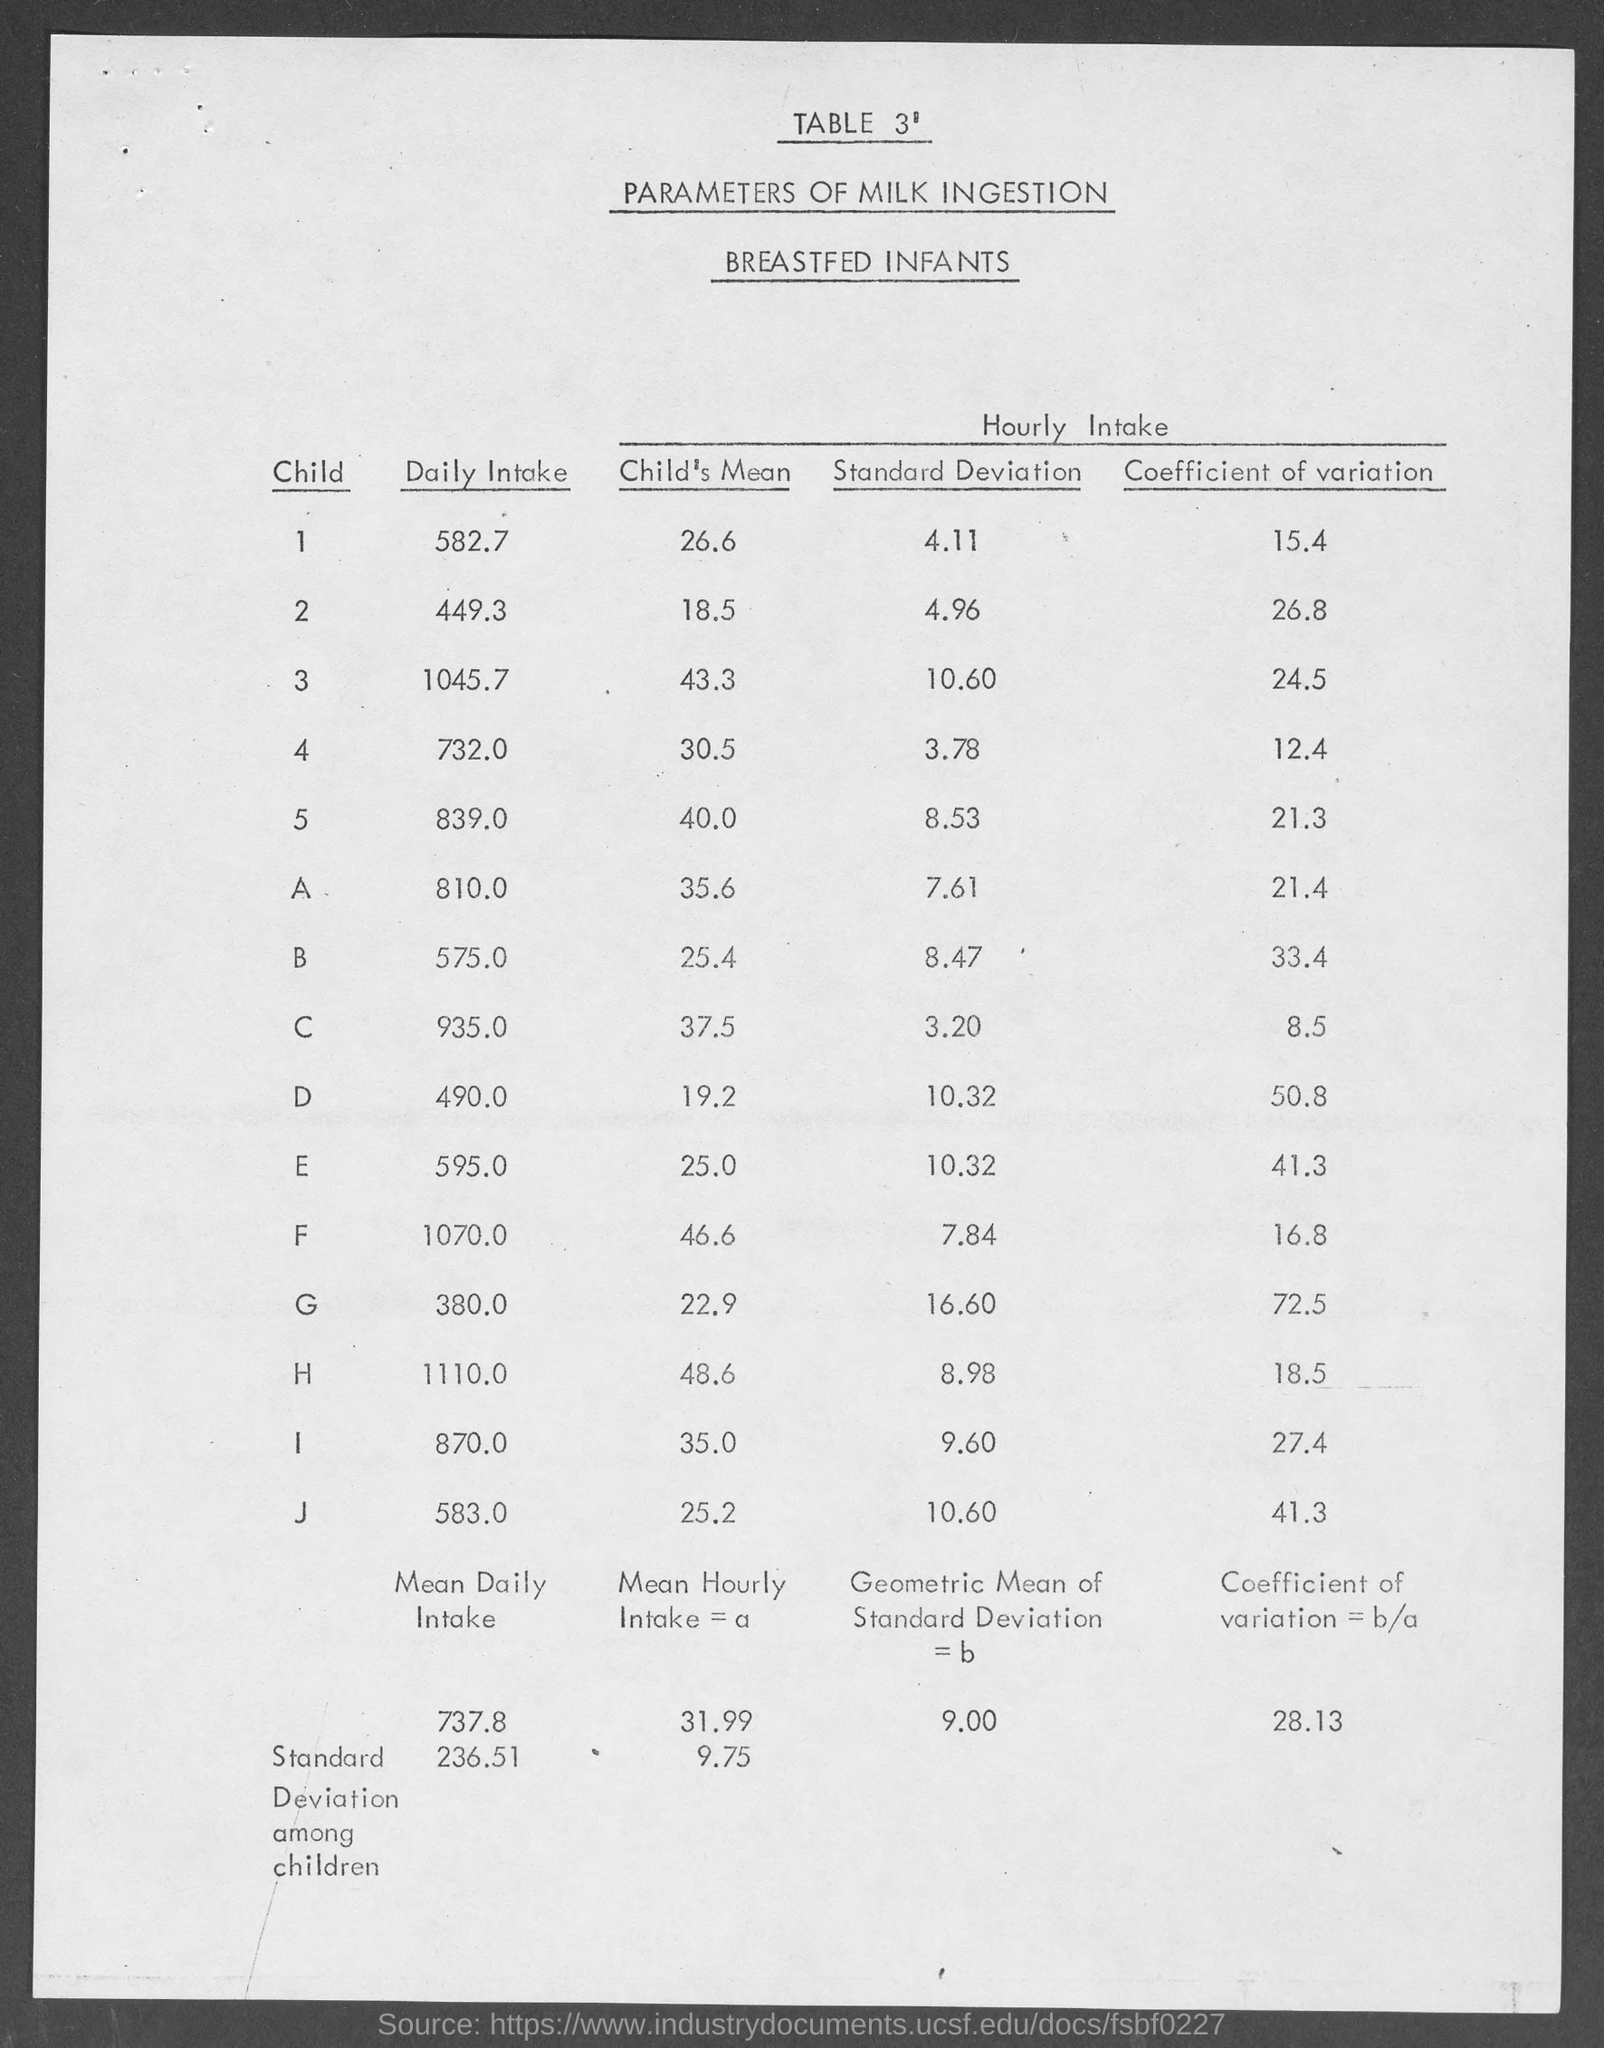Identify some key points in this picture. What is the table number? The daily intake of milk for the first child is approximately 582.7 millimeters. The first column heading of the table is CHILD. 